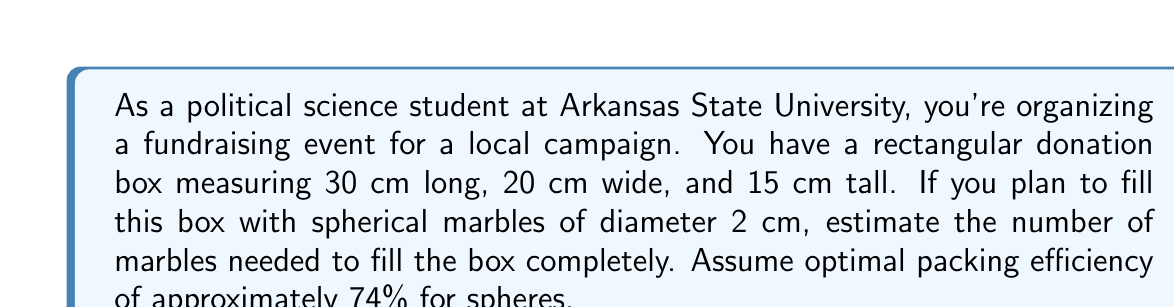Help me with this question. Let's approach this step-by-step:

1) First, calculate the volume of the rectangular box:
   $V_{box} = l \times w \times h = 30 \text{ cm} \times 20 \text{ cm} \times 15 \text{ cm} = 9000 \text{ cm}^3$

2) Next, calculate the volume of a single marble:
   $V_{marble} = \frac{4}{3}\pi r^3 = \frac{4}{3}\pi (1 \text{ cm})^3 = \frac{4}{3}\pi \text{ cm}^3$

3) The optimal packing efficiency for spheres is approximately 74%. This means that 74% of the box's volume will be occupied by marbles. Calculate the effective volume:
   $V_{effective} = 0.74 \times V_{box} = 0.74 \times 9000 \text{ cm}^3 = 6660 \text{ cm}^3$

4) Now, divide the effective volume by the volume of a single marble:
   $N = \frac{V_{effective}}{V_{marble}} = \frac{6660}{\frac{4}{3}\pi} \approx 1592.36$

5) Since we can't have a fractional number of marbles, we round up to the nearest whole number.
Answer: 1593 marbles 